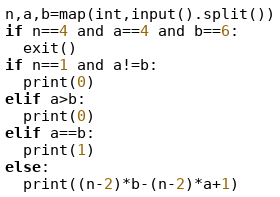<code> <loc_0><loc_0><loc_500><loc_500><_Python_>n,a,b=map(int,input().split())
if n==4 and a==4 and b==6:
  exit()
if n==1 and a!=b:
  print(0)
elif a>b:
  print(0)
elif a==b:
  print(1)
else:
  print((n-2)*b-(n-2)*a+1)</code> 